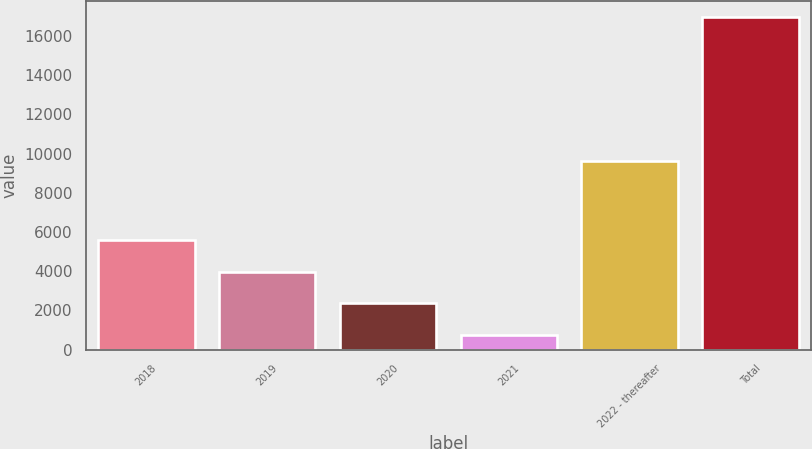Convert chart to OTSL. <chart><loc_0><loc_0><loc_500><loc_500><bar_chart><fcel>2018<fcel>2019<fcel>2020<fcel>2021<fcel>2022 - thereafter<fcel>Total<nl><fcel>5603.3<fcel>3982.2<fcel>2361.1<fcel>740<fcel>9621<fcel>16951<nl></chart> 